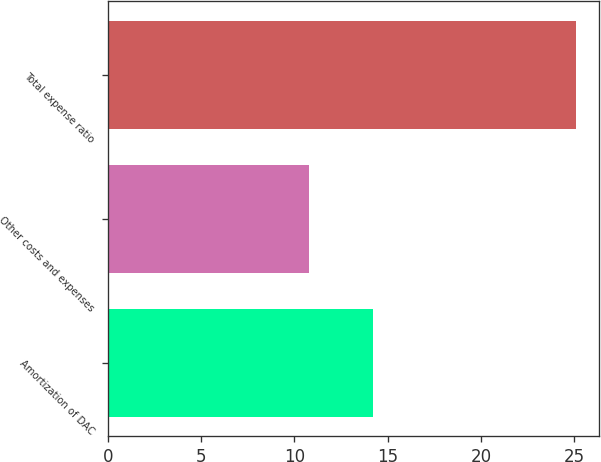Convert chart to OTSL. <chart><loc_0><loc_0><loc_500><loc_500><bar_chart><fcel>Amortization of DAC<fcel>Other costs and expenses<fcel>Total expense ratio<nl><fcel>14.2<fcel>10.8<fcel>25.1<nl></chart> 